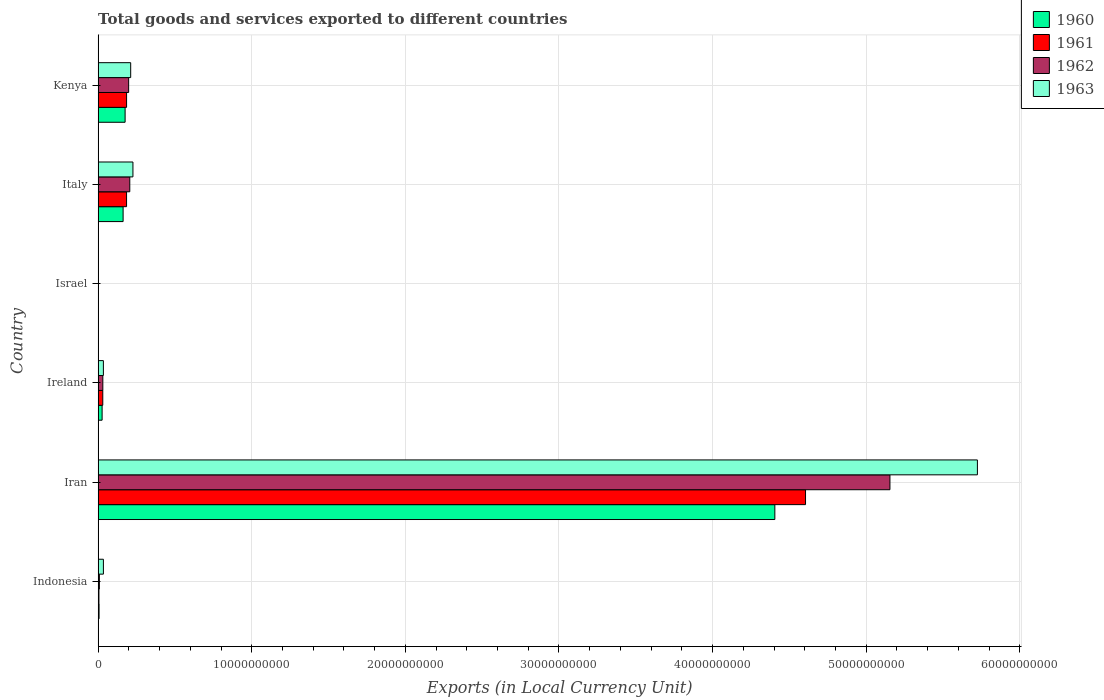Are the number of bars per tick equal to the number of legend labels?
Offer a very short reply. Yes. How many bars are there on the 1st tick from the bottom?
Give a very brief answer. 4. What is the label of the 6th group of bars from the top?
Keep it short and to the point. Indonesia. In how many cases, is the number of bars for a given country not equal to the number of legend labels?
Give a very brief answer. 0. What is the Amount of goods and services exports in 1960 in Ireland?
Offer a very short reply. 2.60e+08. Across all countries, what is the maximum Amount of goods and services exports in 1963?
Your answer should be compact. 5.72e+1. Across all countries, what is the minimum Amount of goods and services exports in 1961?
Ensure brevity in your answer.  7.24e+04. In which country was the Amount of goods and services exports in 1962 maximum?
Make the answer very short. Iran. What is the total Amount of goods and services exports in 1960 in the graph?
Give a very brief answer. 4.78e+1. What is the difference between the Amount of goods and services exports in 1962 in Iran and that in Ireland?
Provide a short and direct response. 5.12e+1. What is the difference between the Amount of goods and services exports in 1963 in Italy and the Amount of goods and services exports in 1962 in Kenya?
Ensure brevity in your answer.  2.79e+08. What is the average Amount of goods and services exports in 1963 per country?
Make the answer very short. 1.04e+1. What is the difference between the Amount of goods and services exports in 1960 and Amount of goods and services exports in 1961 in Ireland?
Offer a very short reply. -4.43e+07. What is the ratio of the Amount of goods and services exports in 1961 in Ireland to that in Italy?
Your answer should be compact. 0.16. Is the difference between the Amount of goods and services exports in 1960 in Ireland and Israel greater than the difference between the Amount of goods and services exports in 1961 in Ireland and Israel?
Give a very brief answer. No. What is the difference between the highest and the second highest Amount of goods and services exports in 1963?
Ensure brevity in your answer.  5.50e+1. What is the difference between the highest and the lowest Amount of goods and services exports in 1963?
Your response must be concise. 5.72e+1. How many bars are there?
Offer a very short reply. 24. What is the difference between two consecutive major ticks on the X-axis?
Provide a succinct answer. 1.00e+1. Are the values on the major ticks of X-axis written in scientific E-notation?
Offer a very short reply. No. Does the graph contain grids?
Your answer should be compact. Yes. Where does the legend appear in the graph?
Your response must be concise. Top right. What is the title of the graph?
Your answer should be very brief. Total goods and services exported to different countries. What is the label or title of the X-axis?
Provide a succinct answer. Exports (in Local Currency Unit). What is the Exports (in Local Currency Unit) of 1960 in Indonesia?
Offer a very short reply. 6.20e+07. What is the Exports (in Local Currency Unit) of 1961 in Indonesia?
Your response must be concise. 5.31e+07. What is the Exports (in Local Currency Unit) of 1962 in Indonesia?
Offer a terse response. 8.19e+07. What is the Exports (in Local Currency Unit) in 1963 in Indonesia?
Give a very brief answer. 3.44e+08. What is the Exports (in Local Currency Unit) of 1960 in Iran?
Make the answer very short. 4.41e+1. What is the Exports (in Local Currency Unit) of 1961 in Iran?
Provide a short and direct response. 4.60e+1. What is the Exports (in Local Currency Unit) in 1962 in Iran?
Offer a terse response. 5.15e+1. What is the Exports (in Local Currency Unit) in 1963 in Iran?
Your response must be concise. 5.72e+1. What is the Exports (in Local Currency Unit) of 1960 in Ireland?
Ensure brevity in your answer.  2.60e+08. What is the Exports (in Local Currency Unit) of 1961 in Ireland?
Ensure brevity in your answer.  3.04e+08. What is the Exports (in Local Currency Unit) of 1962 in Ireland?
Give a very brief answer. 3.07e+08. What is the Exports (in Local Currency Unit) of 1963 in Ireland?
Make the answer very short. 3.43e+08. What is the Exports (in Local Currency Unit) of 1960 in Israel?
Make the answer very short. 6.19e+04. What is the Exports (in Local Currency Unit) of 1961 in Israel?
Ensure brevity in your answer.  7.24e+04. What is the Exports (in Local Currency Unit) in 1962 in Israel?
Ensure brevity in your answer.  1.34e+05. What is the Exports (in Local Currency Unit) of 1963 in Israel?
Give a very brief answer. 1.67e+05. What is the Exports (in Local Currency Unit) in 1960 in Italy?
Make the answer very short. 1.63e+09. What is the Exports (in Local Currency Unit) in 1961 in Italy?
Provide a short and direct response. 1.85e+09. What is the Exports (in Local Currency Unit) in 1962 in Italy?
Your answer should be compact. 2.06e+09. What is the Exports (in Local Currency Unit) in 1963 in Italy?
Provide a succinct answer. 2.27e+09. What is the Exports (in Local Currency Unit) of 1960 in Kenya?
Provide a short and direct response. 1.76e+09. What is the Exports (in Local Currency Unit) of 1961 in Kenya?
Make the answer very short. 1.85e+09. What is the Exports (in Local Currency Unit) of 1962 in Kenya?
Keep it short and to the point. 1.99e+09. What is the Exports (in Local Currency Unit) of 1963 in Kenya?
Offer a very short reply. 2.12e+09. Across all countries, what is the maximum Exports (in Local Currency Unit) of 1960?
Your response must be concise. 4.41e+1. Across all countries, what is the maximum Exports (in Local Currency Unit) in 1961?
Your response must be concise. 4.60e+1. Across all countries, what is the maximum Exports (in Local Currency Unit) in 1962?
Keep it short and to the point. 5.15e+1. Across all countries, what is the maximum Exports (in Local Currency Unit) in 1963?
Your answer should be compact. 5.72e+1. Across all countries, what is the minimum Exports (in Local Currency Unit) in 1960?
Your answer should be very brief. 6.19e+04. Across all countries, what is the minimum Exports (in Local Currency Unit) in 1961?
Offer a terse response. 7.24e+04. Across all countries, what is the minimum Exports (in Local Currency Unit) in 1962?
Provide a short and direct response. 1.34e+05. Across all countries, what is the minimum Exports (in Local Currency Unit) of 1963?
Your answer should be very brief. 1.67e+05. What is the total Exports (in Local Currency Unit) of 1960 in the graph?
Your answer should be compact. 4.78e+1. What is the total Exports (in Local Currency Unit) in 1961 in the graph?
Provide a succinct answer. 5.01e+1. What is the total Exports (in Local Currency Unit) of 1962 in the graph?
Offer a terse response. 5.60e+1. What is the total Exports (in Local Currency Unit) of 1963 in the graph?
Ensure brevity in your answer.  6.23e+1. What is the difference between the Exports (in Local Currency Unit) of 1960 in Indonesia and that in Iran?
Your answer should be compact. -4.40e+1. What is the difference between the Exports (in Local Currency Unit) in 1961 in Indonesia and that in Iran?
Keep it short and to the point. -4.60e+1. What is the difference between the Exports (in Local Currency Unit) in 1962 in Indonesia and that in Iran?
Offer a terse response. -5.15e+1. What is the difference between the Exports (in Local Currency Unit) in 1963 in Indonesia and that in Iran?
Offer a terse response. -5.69e+1. What is the difference between the Exports (in Local Currency Unit) in 1960 in Indonesia and that in Ireland?
Your response must be concise. -1.98e+08. What is the difference between the Exports (in Local Currency Unit) in 1961 in Indonesia and that in Ireland?
Your response must be concise. -2.51e+08. What is the difference between the Exports (in Local Currency Unit) of 1962 in Indonesia and that in Ireland?
Give a very brief answer. -2.25e+08. What is the difference between the Exports (in Local Currency Unit) of 1963 in Indonesia and that in Ireland?
Provide a short and direct response. 1.22e+06. What is the difference between the Exports (in Local Currency Unit) of 1960 in Indonesia and that in Israel?
Keep it short and to the point. 6.19e+07. What is the difference between the Exports (in Local Currency Unit) of 1961 in Indonesia and that in Israel?
Provide a short and direct response. 5.31e+07. What is the difference between the Exports (in Local Currency Unit) of 1962 in Indonesia and that in Israel?
Provide a short and direct response. 8.18e+07. What is the difference between the Exports (in Local Currency Unit) in 1963 in Indonesia and that in Israel?
Ensure brevity in your answer.  3.44e+08. What is the difference between the Exports (in Local Currency Unit) of 1960 in Indonesia and that in Italy?
Ensure brevity in your answer.  -1.56e+09. What is the difference between the Exports (in Local Currency Unit) of 1961 in Indonesia and that in Italy?
Provide a short and direct response. -1.80e+09. What is the difference between the Exports (in Local Currency Unit) in 1962 in Indonesia and that in Italy?
Ensure brevity in your answer.  -1.98e+09. What is the difference between the Exports (in Local Currency Unit) of 1963 in Indonesia and that in Italy?
Your answer should be compact. -1.92e+09. What is the difference between the Exports (in Local Currency Unit) of 1960 in Indonesia and that in Kenya?
Your answer should be very brief. -1.70e+09. What is the difference between the Exports (in Local Currency Unit) of 1961 in Indonesia and that in Kenya?
Offer a very short reply. -1.80e+09. What is the difference between the Exports (in Local Currency Unit) in 1962 in Indonesia and that in Kenya?
Your response must be concise. -1.90e+09. What is the difference between the Exports (in Local Currency Unit) of 1963 in Indonesia and that in Kenya?
Your answer should be compact. -1.78e+09. What is the difference between the Exports (in Local Currency Unit) of 1960 in Iran and that in Ireland?
Your answer should be very brief. 4.38e+1. What is the difference between the Exports (in Local Currency Unit) of 1961 in Iran and that in Ireland?
Provide a succinct answer. 4.57e+1. What is the difference between the Exports (in Local Currency Unit) of 1962 in Iran and that in Ireland?
Your response must be concise. 5.12e+1. What is the difference between the Exports (in Local Currency Unit) in 1963 in Iran and that in Ireland?
Offer a very short reply. 5.69e+1. What is the difference between the Exports (in Local Currency Unit) in 1960 in Iran and that in Israel?
Give a very brief answer. 4.41e+1. What is the difference between the Exports (in Local Currency Unit) in 1961 in Iran and that in Israel?
Offer a terse response. 4.60e+1. What is the difference between the Exports (in Local Currency Unit) of 1962 in Iran and that in Israel?
Your answer should be compact. 5.15e+1. What is the difference between the Exports (in Local Currency Unit) of 1963 in Iran and that in Israel?
Make the answer very short. 5.72e+1. What is the difference between the Exports (in Local Currency Unit) of 1960 in Iran and that in Italy?
Offer a terse response. 4.24e+1. What is the difference between the Exports (in Local Currency Unit) in 1961 in Iran and that in Italy?
Your answer should be compact. 4.42e+1. What is the difference between the Exports (in Local Currency Unit) in 1962 in Iran and that in Italy?
Make the answer very short. 4.95e+1. What is the difference between the Exports (in Local Currency Unit) in 1963 in Iran and that in Italy?
Ensure brevity in your answer.  5.50e+1. What is the difference between the Exports (in Local Currency Unit) of 1960 in Iran and that in Kenya?
Give a very brief answer. 4.23e+1. What is the difference between the Exports (in Local Currency Unit) of 1961 in Iran and that in Kenya?
Provide a succinct answer. 4.42e+1. What is the difference between the Exports (in Local Currency Unit) of 1962 in Iran and that in Kenya?
Give a very brief answer. 4.96e+1. What is the difference between the Exports (in Local Currency Unit) in 1963 in Iran and that in Kenya?
Give a very brief answer. 5.51e+1. What is the difference between the Exports (in Local Currency Unit) in 1960 in Ireland and that in Israel?
Make the answer very short. 2.60e+08. What is the difference between the Exports (in Local Currency Unit) of 1961 in Ireland and that in Israel?
Offer a very short reply. 3.04e+08. What is the difference between the Exports (in Local Currency Unit) of 1962 in Ireland and that in Israel?
Offer a terse response. 3.06e+08. What is the difference between the Exports (in Local Currency Unit) of 1963 in Ireland and that in Israel?
Keep it short and to the point. 3.43e+08. What is the difference between the Exports (in Local Currency Unit) in 1960 in Ireland and that in Italy?
Your answer should be compact. -1.37e+09. What is the difference between the Exports (in Local Currency Unit) of 1961 in Ireland and that in Italy?
Ensure brevity in your answer.  -1.55e+09. What is the difference between the Exports (in Local Currency Unit) in 1962 in Ireland and that in Italy?
Keep it short and to the point. -1.75e+09. What is the difference between the Exports (in Local Currency Unit) of 1963 in Ireland and that in Italy?
Offer a terse response. -1.92e+09. What is the difference between the Exports (in Local Currency Unit) of 1960 in Ireland and that in Kenya?
Your answer should be compact. -1.50e+09. What is the difference between the Exports (in Local Currency Unit) of 1961 in Ireland and that in Kenya?
Your answer should be compact. -1.55e+09. What is the difference between the Exports (in Local Currency Unit) in 1962 in Ireland and that in Kenya?
Your response must be concise. -1.68e+09. What is the difference between the Exports (in Local Currency Unit) of 1963 in Ireland and that in Kenya?
Give a very brief answer. -1.78e+09. What is the difference between the Exports (in Local Currency Unit) in 1960 in Israel and that in Italy?
Provide a short and direct response. -1.63e+09. What is the difference between the Exports (in Local Currency Unit) in 1961 in Israel and that in Italy?
Offer a terse response. -1.85e+09. What is the difference between the Exports (in Local Currency Unit) of 1962 in Israel and that in Italy?
Ensure brevity in your answer.  -2.06e+09. What is the difference between the Exports (in Local Currency Unit) of 1963 in Israel and that in Italy?
Offer a very short reply. -2.27e+09. What is the difference between the Exports (in Local Currency Unit) in 1960 in Israel and that in Kenya?
Offer a very short reply. -1.76e+09. What is the difference between the Exports (in Local Currency Unit) of 1961 in Israel and that in Kenya?
Offer a very short reply. -1.85e+09. What is the difference between the Exports (in Local Currency Unit) in 1962 in Israel and that in Kenya?
Offer a very short reply. -1.99e+09. What is the difference between the Exports (in Local Currency Unit) in 1963 in Israel and that in Kenya?
Give a very brief answer. -2.12e+09. What is the difference between the Exports (in Local Currency Unit) of 1960 in Italy and that in Kenya?
Your answer should be very brief. -1.31e+08. What is the difference between the Exports (in Local Currency Unit) of 1961 in Italy and that in Kenya?
Provide a succinct answer. -1.45e+06. What is the difference between the Exports (in Local Currency Unit) in 1962 in Italy and that in Kenya?
Your response must be concise. 7.40e+07. What is the difference between the Exports (in Local Currency Unit) of 1963 in Italy and that in Kenya?
Your answer should be very brief. 1.46e+08. What is the difference between the Exports (in Local Currency Unit) of 1960 in Indonesia and the Exports (in Local Currency Unit) of 1961 in Iran?
Make the answer very short. -4.60e+1. What is the difference between the Exports (in Local Currency Unit) of 1960 in Indonesia and the Exports (in Local Currency Unit) of 1962 in Iran?
Provide a succinct answer. -5.15e+1. What is the difference between the Exports (in Local Currency Unit) of 1960 in Indonesia and the Exports (in Local Currency Unit) of 1963 in Iran?
Your response must be concise. -5.72e+1. What is the difference between the Exports (in Local Currency Unit) of 1961 in Indonesia and the Exports (in Local Currency Unit) of 1962 in Iran?
Ensure brevity in your answer.  -5.15e+1. What is the difference between the Exports (in Local Currency Unit) in 1961 in Indonesia and the Exports (in Local Currency Unit) in 1963 in Iran?
Your answer should be very brief. -5.72e+1. What is the difference between the Exports (in Local Currency Unit) of 1962 in Indonesia and the Exports (in Local Currency Unit) of 1963 in Iran?
Provide a short and direct response. -5.72e+1. What is the difference between the Exports (in Local Currency Unit) of 1960 in Indonesia and the Exports (in Local Currency Unit) of 1961 in Ireland?
Your answer should be compact. -2.42e+08. What is the difference between the Exports (in Local Currency Unit) of 1960 in Indonesia and the Exports (in Local Currency Unit) of 1962 in Ireland?
Keep it short and to the point. -2.45e+08. What is the difference between the Exports (in Local Currency Unit) in 1960 in Indonesia and the Exports (in Local Currency Unit) in 1963 in Ireland?
Offer a terse response. -2.81e+08. What is the difference between the Exports (in Local Currency Unit) of 1961 in Indonesia and the Exports (in Local Currency Unit) of 1962 in Ireland?
Give a very brief answer. -2.53e+08. What is the difference between the Exports (in Local Currency Unit) of 1961 in Indonesia and the Exports (in Local Currency Unit) of 1963 in Ireland?
Your answer should be very brief. -2.90e+08. What is the difference between the Exports (in Local Currency Unit) of 1962 in Indonesia and the Exports (in Local Currency Unit) of 1963 in Ireland?
Make the answer very short. -2.61e+08. What is the difference between the Exports (in Local Currency Unit) of 1960 in Indonesia and the Exports (in Local Currency Unit) of 1961 in Israel?
Ensure brevity in your answer.  6.19e+07. What is the difference between the Exports (in Local Currency Unit) in 1960 in Indonesia and the Exports (in Local Currency Unit) in 1962 in Israel?
Provide a succinct answer. 6.18e+07. What is the difference between the Exports (in Local Currency Unit) of 1960 in Indonesia and the Exports (in Local Currency Unit) of 1963 in Israel?
Make the answer very short. 6.18e+07. What is the difference between the Exports (in Local Currency Unit) of 1961 in Indonesia and the Exports (in Local Currency Unit) of 1962 in Israel?
Offer a terse response. 5.30e+07. What is the difference between the Exports (in Local Currency Unit) of 1961 in Indonesia and the Exports (in Local Currency Unit) of 1963 in Israel?
Provide a short and direct response. 5.30e+07. What is the difference between the Exports (in Local Currency Unit) of 1962 in Indonesia and the Exports (in Local Currency Unit) of 1963 in Israel?
Offer a terse response. 8.17e+07. What is the difference between the Exports (in Local Currency Unit) of 1960 in Indonesia and the Exports (in Local Currency Unit) of 1961 in Italy?
Keep it short and to the point. -1.79e+09. What is the difference between the Exports (in Local Currency Unit) of 1960 in Indonesia and the Exports (in Local Currency Unit) of 1962 in Italy?
Your response must be concise. -2.00e+09. What is the difference between the Exports (in Local Currency Unit) of 1960 in Indonesia and the Exports (in Local Currency Unit) of 1963 in Italy?
Offer a very short reply. -2.20e+09. What is the difference between the Exports (in Local Currency Unit) of 1961 in Indonesia and the Exports (in Local Currency Unit) of 1962 in Italy?
Ensure brevity in your answer.  -2.01e+09. What is the difference between the Exports (in Local Currency Unit) of 1961 in Indonesia and the Exports (in Local Currency Unit) of 1963 in Italy?
Give a very brief answer. -2.21e+09. What is the difference between the Exports (in Local Currency Unit) in 1962 in Indonesia and the Exports (in Local Currency Unit) in 1963 in Italy?
Offer a very short reply. -2.18e+09. What is the difference between the Exports (in Local Currency Unit) in 1960 in Indonesia and the Exports (in Local Currency Unit) in 1961 in Kenya?
Your answer should be very brief. -1.79e+09. What is the difference between the Exports (in Local Currency Unit) of 1960 in Indonesia and the Exports (in Local Currency Unit) of 1962 in Kenya?
Offer a terse response. -1.92e+09. What is the difference between the Exports (in Local Currency Unit) in 1960 in Indonesia and the Exports (in Local Currency Unit) in 1963 in Kenya?
Make the answer very short. -2.06e+09. What is the difference between the Exports (in Local Currency Unit) in 1961 in Indonesia and the Exports (in Local Currency Unit) in 1962 in Kenya?
Your answer should be compact. -1.93e+09. What is the difference between the Exports (in Local Currency Unit) in 1961 in Indonesia and the Exports (in Local Currency Unit) in 1963 in Kenya?
Ensure brevity in your answer.  -2.07e+09. What is the difference between the Exports (in Local Currency Unit) in 1962 in Indonesia and the Exports (in Local Currency Unit) in 1963 in Kenya?
Keep it short and to the point. -2.04e+09. What is the difference between the Exports (in Local Currency Unit) in 1960 in Iran and the Exports (in Local Currency Unit) in 1961 in Ireland?
Offer a very short reply. 4.37e+1. What is the difference between the Exports (in Local Currency Unit) in 1960 in Iran and the Exports (in Local Currency Unit) in 1962 in Ireland?
Make the answer very short. 4.37e+1. What is the difference between the Exports (in Local Currency Unit) in 1960 in Iran and the Exports (in Local Currency Unit) in 1963 in Ireland?
Make the answer very short. 4.37e+1. What is the difference between the Exports (in Local Currency Unit) in 1961 in Iran and the Exports (in Local Currency Unit) in 1962 in Ireland?
Your response must be concise. 4.57e+1. What is the difference between the Exports (in Local Currency Unit) of 1961 in Iran and the Exports (in Local Currency Unit) of 1963 in Ireland?
Keep it short and to the point. 4.57e+1. What is the difference between the Exports (in Local Currency Unit) of 1962 in Iran and the Exports (in Local Currency Unit) of 1963 in Ireland?
Your answer should be compact. 5.12e+1. What is the difference between the Exports (in Local Currency Unit) of 1960 in Iran and the Exports (in Local Currency Unit) of 1961 in Israel?
Your answer should be compact. 4.41e+1. What is the difference between the Exports (in Local Currency Unit) in 1960 in Iran and the Exports (in Local Currency Unit) in 1962 in Israel?
Your response must be concise. 4.41e+1. What is the difference between the Exports (in Local Currency Unit) of 1960 in Iran and the Exports (in Local Currency Unit) of 1963 in Israel?
Your answer should be compact. 4.41e+1. What is the difference between the Exports (in Local Currency Unit) in 1961 in Iran and the Exports (in Local Currency Unit) in 1962 in Israel?
Keep it short and to the point. 4.60e+1. What is the difference between the Exports (in Local Currency Unit) in 1961 in Iran and the Exports (in Local Currency Unit) in 1963 in Israel?
Your answer should be very brief. 4.60e+1. What is the difference between the Exports (in Local Currency Unit) of 1962 in Iran and the Exports (in Local Currency Unit) of 1963 in Israel?
Provide a succinct answer. 5.15e+1. What is the difference between the Exports (in Local Currency Unit) in 1960 in Iran and the Exports (in Local Currency Unit) in 1961 in Italy?
Provide a short and direct response. 4.22e+1. What is the difference between the Exports (in Local Currency Unit) in 1960 in Iran and the Exports (in Local Currency Unit) in 1962 in Italy?
Make the answer very short. 4.20e+1. What is the difference between the Exports (in Local Currency Unit) in 1960 in Iran and the Exports (in Local Currency Unit) in 1963 in Italy?
Ensure brevity in your answer.  4.18e+1. What is the difference between the Exports (in Local Currency Unit) of 1961 in Iran and the Exports (in Local Currency Unit) of 1962 in Italy?
Offer a terse response. 4.40e+1. What is the difference between the Exports (in Local Currency Unit) of 1961 in Iran and the Exports (in Local Currency Unit) of 1963 in Italy?
Provide a succinct answer. 4.38e+1. What is the difference between the Exports (in Local Currency Unit) in 1962 in Iran and the Exports (in Local Currency Unit) in 1963 in Italy?
Keep it short and to the point. 4.93e+1. What is the difference between the Exports (in Local Currency Unit) of 1960 in Iran and the Exports (in Local Currency Unit) of 1961 in Kenya?
Offer a terse response. 4.22e+1. What is the difference between the Exports (in Local Currency Unit) of 1960 in Iran and the Exports (in Local Currency Unit) of 1962 in Kenya?
Offer a terse response. 4.21e+1. What is the difference between the Exports (in Local Currency Unit) in 1960 in Iran and the Exports (in Local Currency Unit) in 1963 in Kenya?
Ensure brevity in your answer.  4.19e+1. What is the difference between the Exports (in Local Currency Unit) of 1961 in Iran and the Exports (in Local Currency Unit) of 1962 in Kenya?
Your response must be concise. 4.41e+1. What is the difference between the Exports (in Local Currency Unit) of 1961 in Iran and the Exports (in Local Currency Unit) of 1963 in Kenya?
Your answer should be very brief. 4.39e+1. What is the difference between the Exports (in Local Currency Unit) of 1962 in Iran and the Exports (in Local Currency Unit) of 1963 in Kenya?
Ensure brevity in your answer.  4.94e+1. What is the difference between the Exports (in Local Currency Unit) in 1960 in Ireland and the Exports (in Local Currency Unit) in 1961 in Israel?
Your answer should be very brief. 2.60e+08. What is the difference between the Exports (in Local Currency Unit) in 1960 in Ireland and the Exports (in Local Currency Unit) in 1962 in Israel?
Give a very brief answer. 2.60e+08. What is the difference between the Exports (in Local Currency Unit) of 1960 in Ireland and the Exports (in Local Currency Unit) of 1963 in Israel?
Your response must be concise. 2.60e+08. What is the difference between the Exports (in Local Currency Unit) of 1961 in Ireland and the Exports (in Local Currency Unit) of 1962 in Israel?
Ensure brevity in your answer.  3.04e+08. What is the difference between the Exports (in Local Currency Unit) of 1961 in Ireland and the Exports (in Local Currency Unit) of 1963 in Israel?
Offer a terse response. 3.04e+08. What is the difference between the Exports (in Local Currency Unit) of 1962 in Ireland and the Exports (in Local Currency Unit) of 1963 in Israel?
Your answer should be very brief. 3.06e+08. What is the difference between the Exports (in Local Currency Unit) of 1960 in Ireland and the Exports (in Local Currency Unit) of 1961 in Italy?
Your answer should be very brief. -1.59e+09. What is the difference between the Exports (in Local Currency Unit) of 1960 in Ireland and the Exports (in Local Currency Unit) of 1962 in Italy?
Ensure brevity in your answer.  -1.80e+09. What is the difference between the Exports (in Local Currency Unit) in 1960 in Ireland and the Exports (in Local Currency Unit) in 1963 in Italy?
Provide a short and direct response. -2.01e+09. What is the difference between the Exports (in Local Currency Unit) of 1961 in Ireland and the Exports (in Local Currency Unit) of 1962 in Italy?
Provide a succinct answer. -1.76e+09. What is the difference between the Exports (in Local Currency Unit) in 1961 in Ireland and the Exports (in Local Currency Unit) in 1963 in Italy?
Your answer should be very brief. -1.96e+09. What is the difference between the Exports (in Local Currency Unit) of 1962 in Ireland and the Exports (in Local Currency Unit) of 1963 in Italy?
Your answer should be very brief. -1.96e+09. What is the difference between the Exports (in Local Currency Unit) in 1960 in Ireland and the Exports (in Local Currency Unit) in 1961 in Kenya?
Offer a terse response. -1.59e+09. What is the difference between the Exports (in Local Currency Unit) of 1960 in Ireland and the Exports (in Local Currency Unit) of 1962 in Kenya?
Make the answer very short. -1.73e+09. What is the difference between the Exports (in Local Currency Unit) in 1960 in Ireland and the Exports (in Local Currency Unit) in 1963 in Kenya?
Keep it short and to the point. -1.86e+09. What is the difference between the Exports (in Local Currency Unit) in 1961 in Ireland and the Exports (in Local Currency Unit) in 1962 in Kenya?
Your answer should be very brief. -1.68e+09. What is the difference between the Exports (in Local Currency Unit) of 1961 in Ireland and the Exports (in Local Currency Unit) of 1963 in Kenya?
Give a very brief answer. -1.82e+09. What is the difference between the Exports (in Local Currency Unit) in 1962 in Ireland and the Exports (in Local Currency Unit) in 1963 in Kenya?
Make the answer very short. -1.81e+09. What is the difference between the Exports (in Local Currency Unit) of 1960 in Israel and the Exports (in Local Currency Unit) of 1961 in Italy?
Offer a very short reply. -1.85e+09. What is the difference between the Exports (in Local Currency Unit) in 1960 in Israel and the Exports (in Local Currency Unit) in 1962 in Italy?
Your answer should be very brief. -2.06e+09. What is the difference between the Exports (in Local Currency Unit) of 1960 in Israel and the Exports (in Local Currency Unit) of 1963 in Italy?
Ensure brevity in your answer.  -2.27e+09. What is the difference between the Exports (in Local Currency Unit) of 1961 in Israel and the Exports (in Local Currency Unit) of 1962 in Italy?
Make the answer very short. -2.06e+09. What is the difference between the Exports (in Local Currency Unit) of 1961 in Israel and the Exports (in Local Currency Unit) of 1963 in Italy?
Your response must be concise. -2.27e+09. What is the difference between the Exports (in Local Currency Unit) in 1962 in Israel and the Exports (in Local Currency Unit) in 1963 in Italy?
Make the answer very short. -2.27e+09. What is the difference between the Exports (in Local Currency Unit) of 1960 in Israel and the Exports (in Local Currency Unit) of 1961 in Kenya?
Give a very brief answer. -1.85e+09. What is the difference between the Exports (in Local Currency Unit) in 1960 in Israel and the Exports (in Local Currency Unit) in 1962 in Kenya?
Make the answer very short. -1.99e+09. What is the difference between the Exports (in Local Currency Unit) of 1960 in Israel and the Exports (in Local Currency Unit) of 1963 in Kenya?
Give a very brief answer. -2.12e+09. What is the difference between the Exports (in Local Currency Unit) of 1961 in Israel and the Exports (in Local Currency Unit) of 1962 in Kenya?
Your answer should be compact. -1.99e+09. What is the difference between the Exports (in Local Currency Unit) in 1961 in Israel and the Exports (in Local Currency Unit) in 1963 in Kenya?
Your answer should be compact. -2.12e+09. What is the difference between the Exports (in Local Currency Unit) in 1962 in Israel and the Exports (in Local Currency Unit) in 1963 in Kenya?
Offer a very short reply. -2.12e+09. What is the difference between the Exports (in Local Currency Unit) in 1960 in Italy and the Exports (in Local Currency Unit) in 1961 in Kenya?
Offer a terse response. -2.27e+08. What is the difference between the Exports (in Local Currency Unit) of 1960 in Italy and the Exports (in Local Currency Unit) of 1962 in Kenya?
Your response must be concise. -3.60e+08. What is the difference between the Exports (in Local Currency Unit) of 1960 in Italy and the Exports (in Local Currency Unit) of 1963 in Kenya?
Give a very brief answer. -4.94e+08. What is the difference between the Exports (in Local Currency Unit) of 1961 in Italy and the Exports (in Local Currency Unit) of 1962 in Kenya?
Offer a terse response. -1.35e+08. What is the difference between the Exports (in Local Currency Unit) of 1961 in Italy and the Exports (in Local Currency Unit) of 1963 in Kenya?
Make the answer very short. -2.68e+08. What is the difference between the Exports (in Local Currency Unit) in 1962 in Italy and the Exports (in Local Currency Unit) in 1963 in Kenya?
Offer a terse response. -5.95e+07. What is the average Exports (in Local Currency Unit) of 1960 per country?
Keep it short and to the point. 7.96e+09. What is the average Exports (in Local Currency Unit) in 1961 per country?
Your answer should be compact. 8.35e+09. What is the average Exports (in Local Currency Unit) of 1962 per country?
Offer a terse response. 9.33e+09. What is the average Exports (in Local Currency Unit) of 1963 per country?
Your answer should be very brief. 1.04e+1. What is the difference between the Exports (in Local Currency Unit) of 1960 and Exports (in Local Currency Unit) of 1961 in Indonesia?
Provide a succinct answer. 8.85e+06. What is the difference between the Exports (in Local Currency Unit) of 1960 and Exports (in Local Currency Unit) of 1962 in Indonesia?
Keep it short and to the point. -1.99e+07. What is the difference between the Exports (in Local Currency Unit) of 1960 and Exports (in Local Currency Unit) of 1963 in Indonesia?
Offer a terse response. -2.82e+08. What is the difference between the Exports (in Local Currency Unit) of 1961 and Exports (in Local Currency Unit) of 1962 in Indonesia?
Offer a terse response. -2.88e+07. What is the difference between the Exports (in Local Currency Unit) of 1961 and Exports (in Local Currency Unit) of 1963 in Indonesia?
Keep it short and to the point. -2.91e+08. What is the difference between the Exports (in Local Currency Unit) of 1962 and Exports (in Local Currency Unit) of 1963 in Indonesia?
Your answer should be very brief. -2.62e+08. What is the difference between the Exports (in Local Currency Unit) in 1960 and Exports (in Local Currency Unit) in 1961 in Iran?
Provide a succinct answer. -2.00e+09. What is the difference between the Exports (in Local Currency Unit) in 1960 and Exports (in Local Currency Unit) in 1962 in Iran?
Provide a short and direct response. -7.49e+09. What is the difference between the Exports (in Local Currency Unit) of 1960 and Exports (in Local Currency Unit) of 1963 in Iran?
Provide a short and direct response. -1.32e+1. What is the difference between the Exports (in Local Currency Unit) in 1961 and Exports (in Local Currency Unit) in 1962 in Iran?
Your answer should be compact. -5.49e+09. What is the difference between the Exports (in Local Currency Unit) in 1961 and Exports (in Local Currency Unit) in 1963 in Iran?
Provide a succinct answer. -1.12e+1. What is the difference between the Exports (in Local Currency Unit) in 1962 and Exports (in Local Currency Unit) in 1963 in Iran?
Provide a succinct answer. -5.69e+09. What is the difference between the Exports (in Local Currency Unit) of 1960 and Exports (in Local Currency Unit) of 1961 in Ireland?
Keep it short and to the point. -4.43e+07. What is the difference between the Exports (in Local Currency Unit) in 1960 and Exports (in Local Currency Unit) in 1962 in Ireland?
Provide a succinct answer. -4.69e+07. What is the difference between the Exports (in Local Currency Unit) in 1960 and Exports (in Local Currency Unit) in 1963 in Ireland?
Ensure brevity in your answer.  -8.33e+07. What is the difference between the Exports (in Local Currency Unit) of 1961 and Exports (in Local Currency Unit) of 1962 in Ireland?
Provide a succinct answer. -2.58e+06. What is the difference between the Exports (in Local Currency Unit) in 1961 and Exports (in Local Currency Unit) in 1963 in Ireland?
Your answer should be very brief. -3.90e+07. What is the difference between the Exports (in Local Currency Unit) of 1962 and Exports (in Local Currency Unit) of 1963 in Ireland?
Offer a very short reply. -3.64e+07. What is the difference between the Exports (in Local Currency Unit) of 1960 and Exports (in Local Currency Unit) of 1961 in Israel?
Offer a terse response. -1.05e+04. What is the difference between the Exports (in Local Currency Unit) in 1960 and Exports (in Local Currency Unit) in 1962 in Israel?
Provide a short and direct response. -7.21e+04. What is the difference between the Exports (in Local Currency Unit) in 1960 and Exports (in Local Currency Unit) in 1963 in Israel?
Your answer should be very brief. -1.06e+05. What is the difference between the Exports (in Local Currency Unit) in 1961 and Exports (in Local Currency Unit) in 1962 in Israel?
Give a very brief answer. -6.16e+04. What is the difference between the Exports (in Local Currency Unit) of 1961 and Exports (in Local Currency Unit) of 1963 in Israel?
Your answer should be compact. -9.50e+04. What is the difference between the Exports (in Local Currency Unit) of 1962 and Exports (in Local Currency Unit) of 1963 in Israel?
Your answer should be compact. -3.34e+04. What is the difference between the Exports (in Local Currency Unit) of 1960 and Exports (in Local Currency Unit) of 1961 in Italy?
Provide a short and direct response. -2.25e+08. What is the difference between the Exports (in Local Currency Unit) in 1960 and Exports (in Local Currency Unit) in 1962 in Italy?
Offer a very short reply. -4.34e+08. What is the difference between the Exports (in Local Currency Unit) in 1960 and Exports (in Local Currency Unit) in 1963 in Italy?
Offer a terse response. -6.40e+08. What is the difference between the Exports (in Local Currency Unit) in 1961 and Exports (in Local Currency Unit) in 1962 in Italy?
Give a very brief answer. -2.09e+08. What is the difference between the Exports (in Local Currency Unit) in 1961 and Exports (in Local Currency Unit) in 1963 in Italy?
Provide a succinct answer. -4.14e+08. What is the difference between the Exports (in Local Currency Unit) of 1962 and Exports (in Local Currency Unit) of 1963 in Italy?
Keep it short and to the point. -2.05e+08. What is the difference between the Exports (in Local Currency Unit) of 1960 and Exports (in Local Currency Unit) of 1961 in Kenya?
Your response must be concise. -9.56e+07. What is the difference between the Exports (in Local Currency Unit) in 1960 and Exports (in Local Currency Unit) in 1962 in Kenya?
Ensure brevity in your answer.  -2.29e+08. What is the difference between the Exports (in Local Currency Unit) in 1960 and Exports (in Local Currency Unit) in 1963 in Kenya?
Your answer should be compact. -3.63e+08. What is the difference between the Exports (in Local Currency Unit) of 1961 and Exports (in Local Currency Unit) of 1962 in Kenya?
Your answer should be very brief. -1.33e+08. What is the difference between the Exports (in Local Currency Unit) in 1961 and Exports (in Local Currency Unit) in 1963 in Kenya?
Ensure brevity in your answer.  -2.67e+08. What is the difference between the Exports (in Local Currency Unit) of 1962 and Exports (in Local Currency Unit) of 1963 in Kenya?
Ensure brevity in your answer.  -1.34e+08. What is the ratio of the Exports (in Local Currency Unit) in 1960 in Indonesia to that in Iran?
Keep it short and to the point. 0. What is the ratio of the Exports (in Local Currency Unit) of 1961 in Indonesia to that in Iran?
Ensure brevity in your answer.  0. What is the ratio of the Exports (in Local Currency Unit) in 1962 in Indonesia to that in Iran?
Keep it short and to the point. 0. What is the ratio of the Exports (in Local Currency Unit) in 1963 in Indonesia to that in Iran?
Offer a very short reply. 0.01. What is the ratio of the Exports (in Local Currency Unit) in 1960 in Indonesia to that in Ireland?
Your response must be concise. 0.24. What is the ratio of the Exports (in Local Currency Unit) in 1961 in Indonesia to that in Ireland?
Ensure brevity in your answer.  0.17. What is the ratio of the Exports (in Local Currency Unit) in 1962 in Indonesia to that in Ireland?
Your answer should be compact. 0.27. What is the ratio of the Exports (in Local Currency Unit) of 1960 in Indonesia to that in Israel?
Your answer should be compact. 1001.31. What is the ratio of the Exports (in Local Currency Unit) in 1961 in Indonesia to that in Israel?
Your answer should be very brief. 733.8. What is the ratio of the Exports (in Local Currency Unit) in 1962 in Indonesia to that in Israel?
Ensure brevity in your answer.  611.22. What is the ratio of the Exports (in Local Currency Unit) in 1963 in Indonesia to that in Israel?
Make the answer very short. 2056.26. What is the ratio of the Exports (in Local Currency Unit) of 1960 in Indonesia to that in Italy?
Offer a very short reply. 0.04. What is the ratio of the Exports (in Local Currency Unit) of 1961 in Indonesia to that in Italy?
Make the answer very short. 0.03. What is the ratio of the Exports (in Local Currency Unit) of 1962 in Indonesia to that in Italy?
Your response must be concise. 0.04. What is the ratio of the Exports (in Local Currency Unit) in 1963 in Indonesia to that in Italy?
Make the answer very short. 0.15. What is the ratio of the Exports (in Local Currency Unit) in 1960 in Indonesia to that in Kenya?
Ensure brevity in your answer.  0.04. What is the ratio of the Exports (in Local Currency Unit) of 1961 in Indonesia to that in Kenya?
Your response must be concise. 0.03. What is the ratio of the Exports (in Local Currency Unit) in 1962 in Indonesia to that in Kenya?
Your answer should be compact. 0.04. What is the ratio of the Exports (in Local Currency Unit) of 1963 in Indonesia to that in Kenya?
Offer a terse response. 0.16. What is the ratio of the Exports (in Local Currency Unit) in 1960 in Iran to that in Ireland?
Make the answer very short. 169.64. What is the ratio of the Exports (in Local Currency Unit) of 1961 in Iran to that in Ireland?
Keep it short and to the point. 151.49. What is the ratio of the Exports (in Local Currency Unit) of 1962 in Iran to that in Ireland?
Offer a very short reply. 168.13. What is the ratio of the Exports (in Local Currency Unit) of 1963 in Iran to that in Ireland?
Your response must be concise. 166.87. What is the ratio of the Exports (in Local Currency Unit) of 1960 in Iran to that in Israel?
Offer a terse response. 7.12e+05. What is the ratio of the Exports (in Local Currency Unit) of 1961 in Iran to that in Israel?
Keep it short and to the point. 6.36e+05. What is the ratio of the Exports (in Local Currency Unit) in 1962 in Iran to that in Israel?
Give a very brief answer. 3.85e+05. What is the ratio of the Exports (in Local Currency Unit) in 1963 in Iran to that in Israel?
Your answer should be compact. 3.42e+05. What is the ratio of the Exports (in Local Currency Unit) of 1960 in Iran to that in Italy?
Give a very brief answer. 27.08. What is the ratio of the Exports (in Local Currency Unit) of 1961 in Iran to that in Italy?
Your answer should be very brief. 24.87. What is the ratio of the Exports (in Local Currency Unit) in 1962 in Iran to that in Italy?
Your answer should be very brief. 25.01. What is the ratio of the Exports (in Local Currency Unit) of 1963 in Iran to that in Italy?
Provide a succinct answer. 25.26. What is the ratio of the Exports (in Local Currency Unit) in 1960 in Iran to that in Kenya?
Offer a very short reply. 25.07. What is the ratio of the Exports (in Local Currency Unit) of 1961 in Iran to that in Kenya?
Keep it short and to the point. 24.85. What is the ratio of the Exports (in Local Currency Unit) of 1962 in Iran to that in Kenya?
Make the answer very short. 25.95. What is the ratio of the Exports (in Local Currency Unit) in 1963 in Iran to that in Kenya?
Keep it short and to the point. 27. What is the ratio of the Exports (in Local Currency Unit) of 1960 in Ireland to that in Israel?
Your answer should be very brief. 4195.01. What is the ratio of the Exports (in Local Currency Unit) of 1961 in Ireland to that in Israel?
Offer a very short reply. 4198.66. What is the ratio of the Exports (in Local Currency Unit) in 1962 in Ireland to that in Israel?
Give a very brief answer. 2287.81. What is the ratio of the Exports (in Local Currency Unit) in 1963 in Ireland to that in Israel?
Provide a succinct answer. 2048.97. What is the ratio of the Exports (in Local Currency Unit) in 1960 in Ireland to that in Italy?
Offer a terse response. 0.16. What is the ratio of the Exports (in Local Currency Unit) in 1961 in Ireland to that in Italy?
Provide a succinct answer. 0.16. What is the ratio of the Exports (in Local Currency Unit) in 1962 in Ireland to that in Italy?
Keep it short and to the point. 0.15. What is the ratio of the Exports (in Local Currency Unit) in 1963 in Ireland to that in Italy?
Your answer should be compact. 0.15. What is the ratio of the Exports (in Local Currency Unit) of 1960 in Ireland to that in Kenya?
Offer a terse response. 0.15. What is the ratio of the Exports (in Local Currency Unit) in 1961 in Ireland to that in Kenya?
Offer a terse response. 0.16. What is the ratio of the Exports (in Local Currency Unit) in 1962 in Ireland to that in Kenya?
Provide a succinct answer. 0.15. What is the ratio of the Exports (in Local Currency Unit) of 1963 in Ireland to that in Kenya?
Provide a short and direct response. 0.16. What is the ratio of the Exports (in Local Currency Unit) of 1960 in Israel to that in Kenya?
Offer a very short reply. 0. What is the ratio of the Exports (in Local Currency Unit) of 1961 in Israel to that in Kenya?
Offer a very short reply. 0. What is the ratio of the Exports (in Local Currency Unit) in 1962 in Israel to that in Kenya?
Your answer should be very brief. 0. What is the ratio of the Exports (in Local Currency Unit) of 1963 in Israel to that in Kenya?
Keep it short and to the point. 0. What is the ratio of the Exports (in Local Currency Unit) in 1960 in Italy to that in Kenya?
Make the answer very short. 0.93. What is the ratio of the Exports (in Local Currency Unit) in 1961 in Italy to that in Kenya?
Ensure brevity in your answer.  1. What is the ratio of the Exports (in Local Currency Unit) in 1962 in Italy to that in Kenya?
Offer a very short reply. 1.04. What is the ratio of the Exports (in Local Currency Unit) in 1963 in Italy to that in Kenya?
Your answer should be very brief. 1.07. What is the difference between the highest and the second highest Exports (in Local Currency Unit) in 1960?
Give a very brief answer. 4.23e+1. What is the difference between the highest and the second highest Exports (in Local Currency Unit) in 1961?
Give a very brief answer. 4.42e+1. What is the difference between the highest and the second highest Exports (in Local Currency Unit) in 1962?
Ensure brevity in your answer.  4.95e+1. What is the difference between the highest and the second highest Exports (in Local Currency Unit) of 1963?
Your answer should be compact. 5.50e+1. What is the difference between the highest and the lowest Exports (in Local Currency Unit) in 1960?
Give a very brief answer. 4.41e+1. What is the difference between the highest and the lowest Exports (in Local Currency Unit) in 1961?
Provide a succinct answer. 4.60e+1. What is the difference between the highest and the lowest Exports (in Local Currency Unit) in 1962?
Keep it short and to the point. 5.15e+1. What is the difference between the highest and the lowest Exports (in Local Currency Unit) in 1963?
Your answer should be very brief. 5.72e+1. 